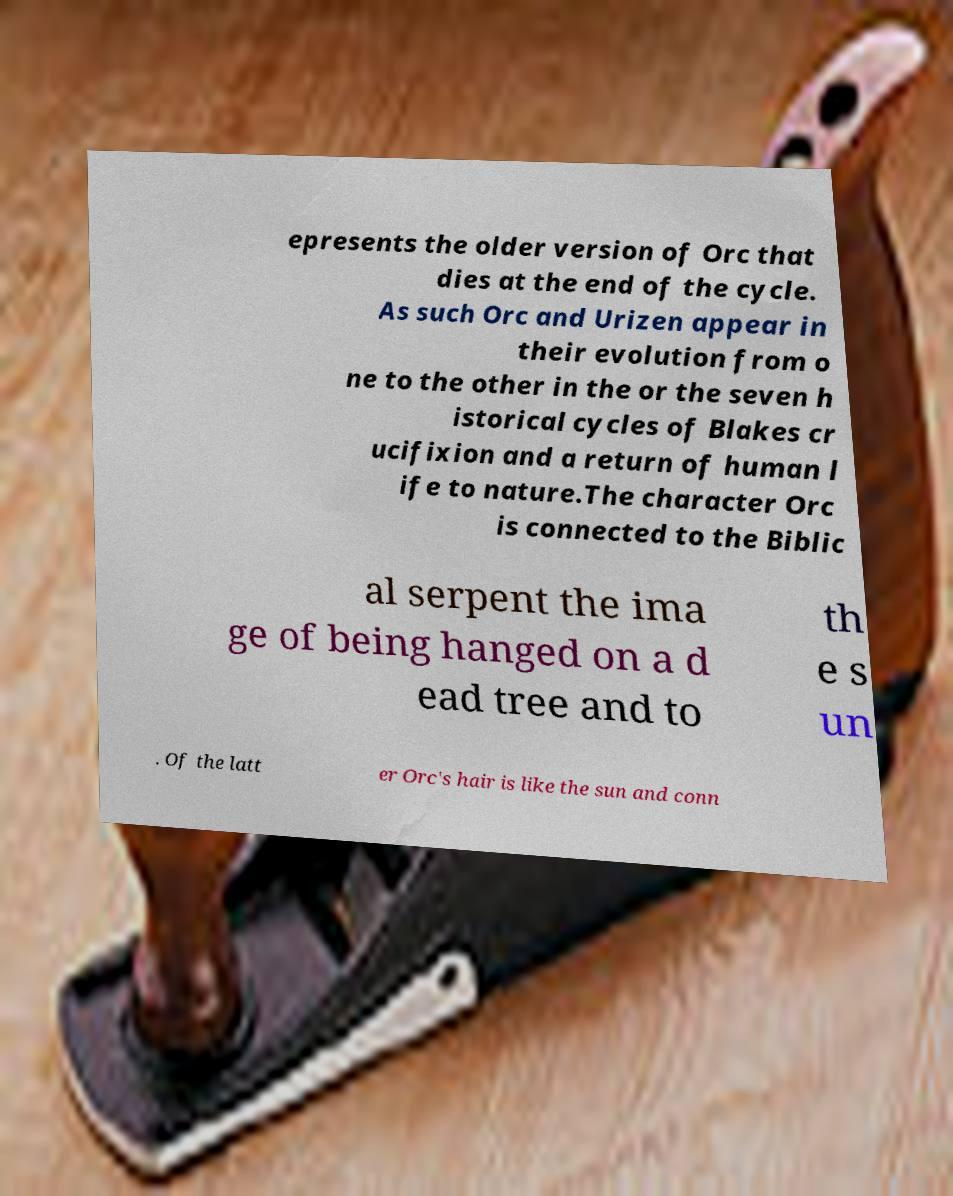Could you extract and type out the text from this image? epresents the older version of Orc that dies at the end of the cycle. As such Orc and Urizen appear in their evolution from o ne to the other in the or the seven h istorical cycles of Blakes cr ucifixion and a return of human l ife to nature.The character Orc is connected to the Biblic al serpent the ima ge of being hanged on a d ead tree and to th e s un . Of the latt er Orc's hair is like the sun and conn 